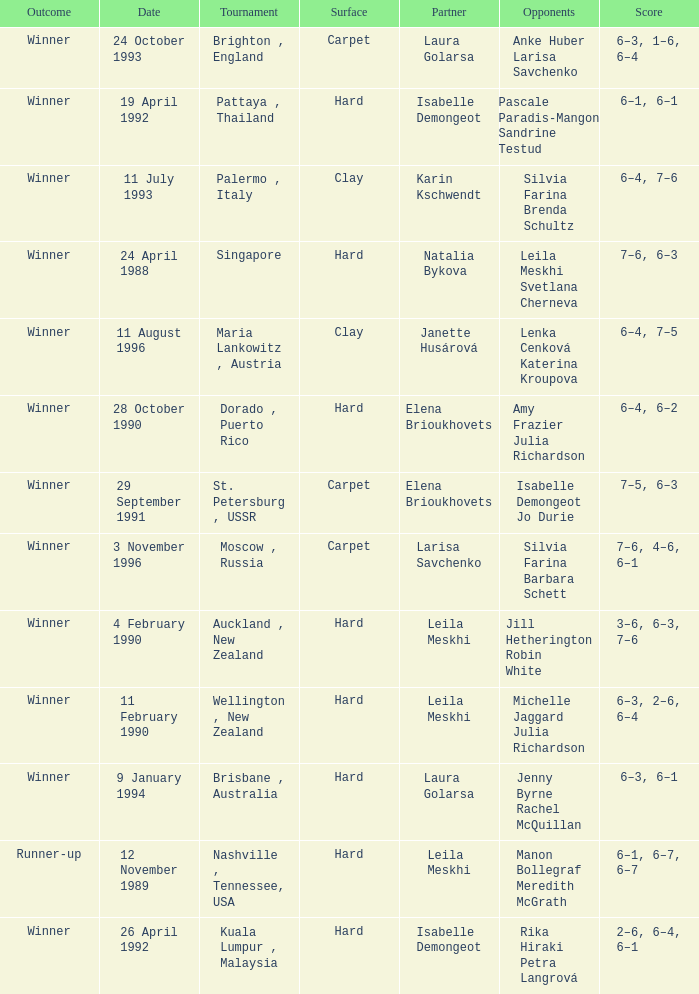In what Tournament was the Score of 3–6, 6–3, 7–6 in a match played on a hard Surface? Auckland , New Zealand. 